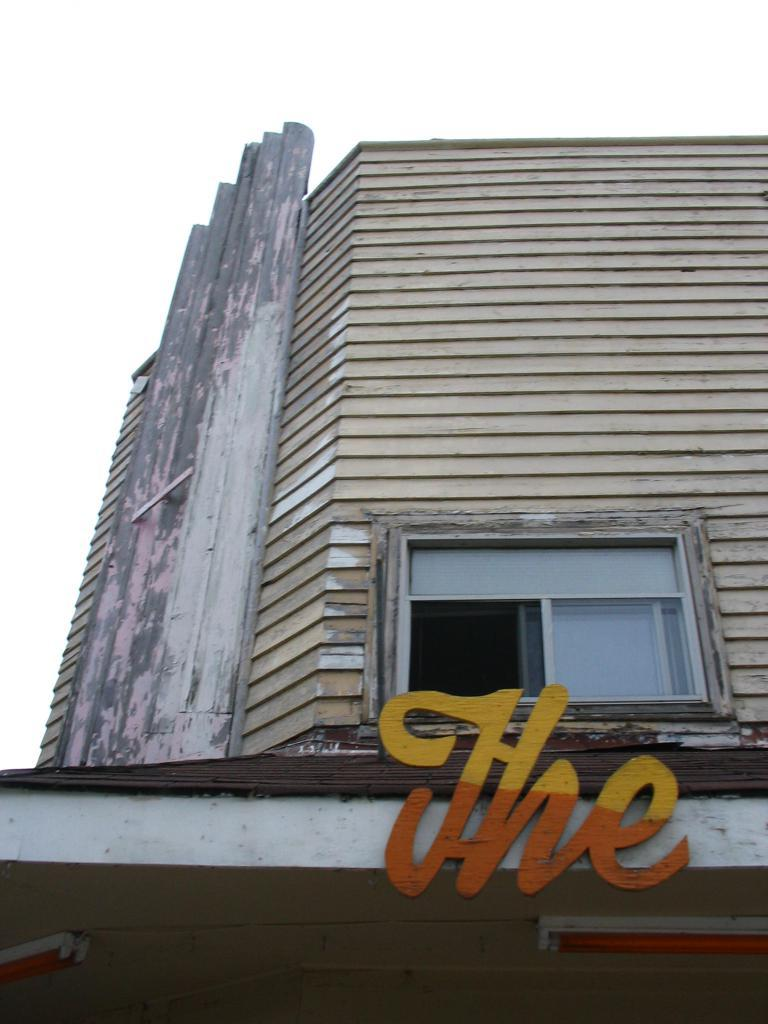What structure can be seen in the image? There is a building in the image. What is written or displayed on the building? There is text on the wall of the building, and it is visible in the image. How would you describe the weather based on the image? The sky is cloudy in the image, which suggests a potentially overcast or cloudy day. What type of reaction can be seen from the quartz in the image? There is no quartz present in the image, so it is not possible to observe any reactions from it. 